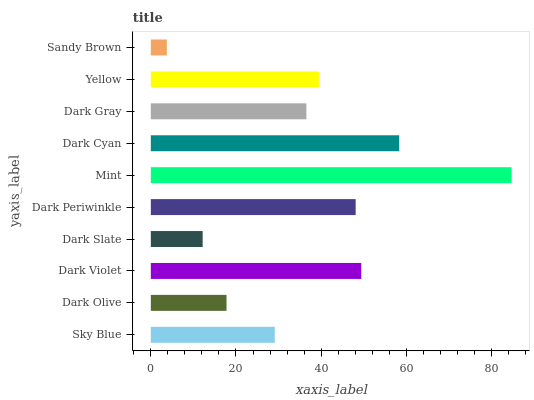Is Sandy Brown the minimum?
Answer yes or no. Yes. Is Mint the maximum?
Answer yes or no. Yes. Is Dark Olive the minimum?
Answer yes or no. No. Is Dark Olive the maximum?
Answer yes or no. No. Is Sky Blue greater than Dark Olive?
Answer yes or no. Yes. Is Dark Olive less than Sky Blue?
Answer yes or no. Yes. Is Dark Olive greater than Sky Blue?
Answer yes or no. No. Is Sky Blue less than Dark Olive?
Answer yes or no. No. Is Yellow the high median?
Answer yes or no. Yes. Is Dark Gray the low median?
Answer yes or no. Yes. Is Dark Violet the high median?
Answer yes or no. No. Is Dark Slate the low median?
Answer yes or no. No. 